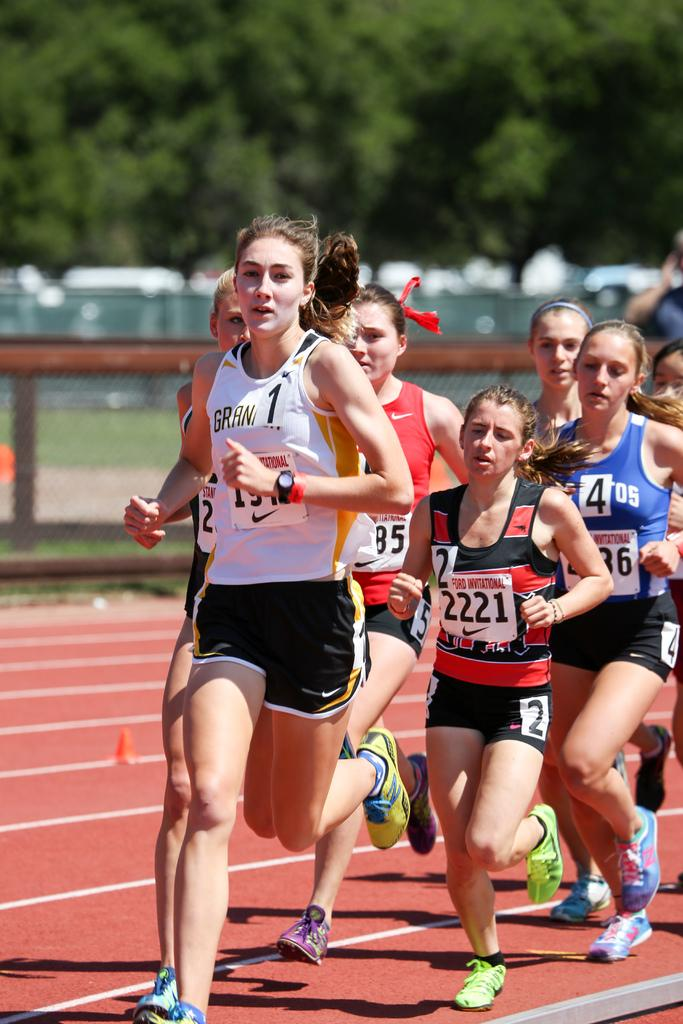What is happening in the image involving a group of women? The women are running on the ground in the image. What can be seen in the background of the image? There are trees in the image, and the background is blurry. What is the purpose of the fence in the image? The purpose of the fence in the image is not specified, but it could be a boundary or a barrier. What type of basket is being used by the women while running in the image? There is no basket present in the image; the women are running without any visible equipment or accessories. 